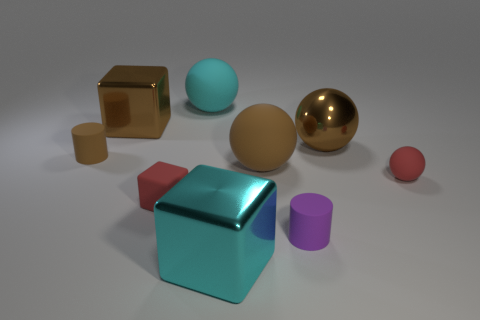What is the size of the brown metallic object that is left of the small thing that is in front of the small red block?
Your response must be concise. Large. How big is the rubber sphere left of the metallic block that is to the right of the large sphere on the left side of the large cyan metallic block?
Your answer should be very brief. Large. There is a rubber thing left of the tiny matte block; is it the same shape as the big metallic thing in front of the big metallic ball?
Provide a short and direct response. No. How many other things are there of the same color as the metallic ball?
Offer a very short reply. 3. Does the cylinder that is to the right of the cyan shiny cube have the same size as the tiny brown cylinder?
Your answer should be very brief. Yes. Is the material of the large brown object that is on the right side of the tiny purple cylinder the same as the sphere that is on the left side of the large cyan block?
Offer a very short reply. No. Are there any brown objects of the same size as the cyan metallic thing?
Keep it short and to the point. Yes. There is a cyan thing right of the large rubber object that is behind the rubber cylinder left of the rubber cube; what is its shape?
Offer a terse response. Cube. Is the number of large metallic objects in front of the brown cube greater than the number of tiny blocks?
Your answer should be very brief. Yes. Is there a tiny brown thing that has the same shape as the purple rubber object?
Give a very brief answer. Yes. 